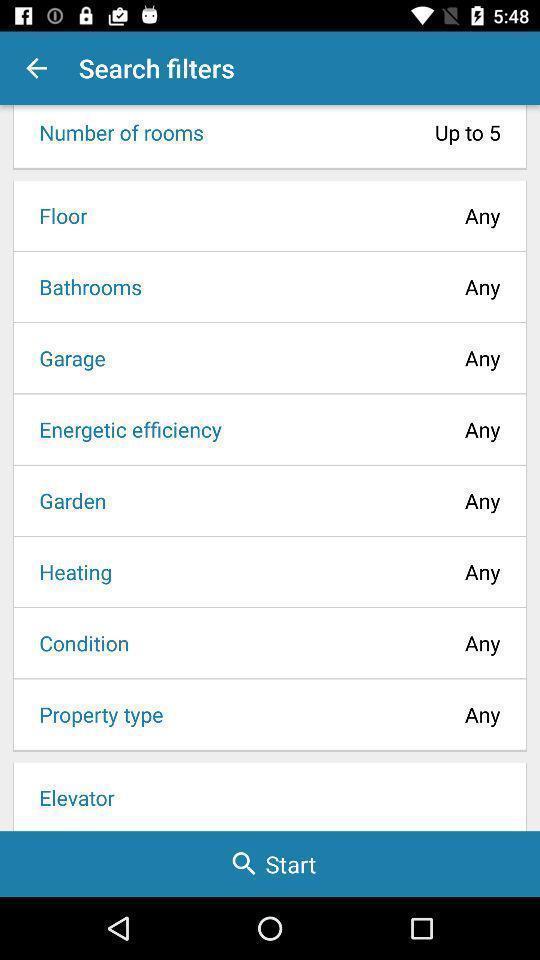Tell me about the visual elements in this screen capture. Search page for searching applied filters. 